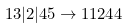<formula> <loc_0><loc_0><loc_500><loc_500>1 3 | 2 | 4 5 \to 1 1 2 4 4</formula> 